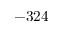Convert formula to latex. <formula><loc_0><loc_0><loc_500><loc_500>- 3 2 4</formula> 